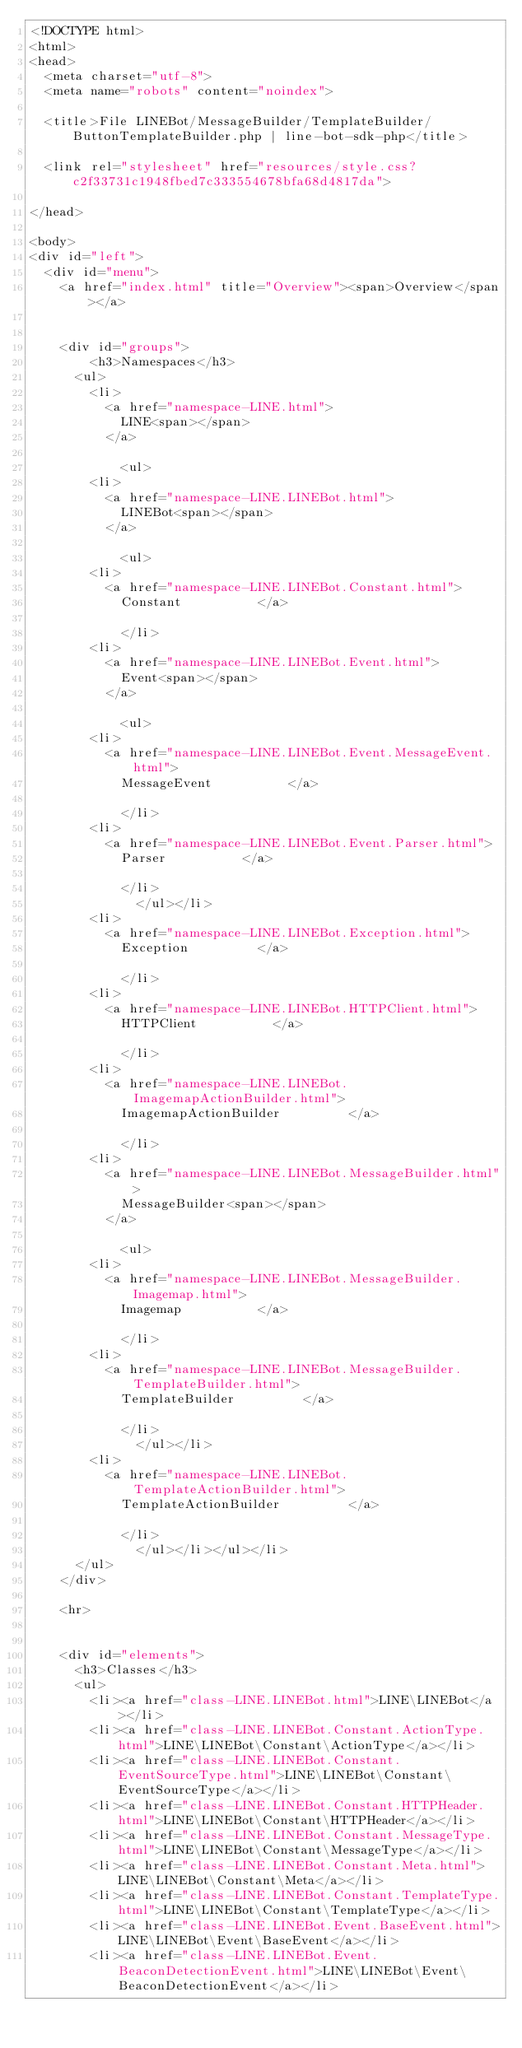Convert code to text. <code><loc_0><loc_0><loc_500><loc_500><_HTML_><!DOCTYPE html>
<html>
<head>
	<meta charset="utf-8">
	<meta name="robots" content="noindex">

	<title>File LINEBot/MessageBuilder/TemplateBuilder/ButtonTemplateBuilder.php | line-bot-sdk-php</title>

	<link rel="stylesheet" href="resources/style.css?c2f33731c1948fbed7c333554678bfa68d4817da">

</head>

<body>
<div id="left">
	<div id="menu">
		<a href="index.html" title="Overview"><span>Overview</span></a>


		<div id="groups">
				<h3>Namespaces</h3>
			<ul>
				<li>
					<a href="namespace-LINE.html">
						LINE<span></span>
					</a>

						<ul>
				<li>
					<a href="namespace-LINE.LINEBot.html">
						LINEBot<span></span>
					</a>

						<ul>
				<li>
					<a href="namespace-LINE.LINEBot.Constant.html">
						Constant					</a>

						</li>
				<li>
					<a href="namespace-LINE.LINEBot.Event.html">
						Event<span></span>
					</a>

						<ul>
				<li>
					<a href="namespace-LINE.LINEBot.Event.MessageEvent.html">
						MessageEvent					</a>

						</li>
				<li>
					<a href="namespace-LINE.LINEBot.Event.Parser.html">
						Parser					</a>

						</li>
							</ul></li>
				<li>
					<a href="namespace-LINE.LINEBot.Exception.html">
						Exception					</a>

						</li>
				<li>
					<a href="namespace-LINE.LINEBot.HTTPClient.html">
						HTTPClient					</a>

						</li>
				<li>
					<a href="namespace-LINE.LINEBot.ImagemapActionBuilder.html">
						ImagemapActionBuilder					</a>

						</li>
				<li>
					<a href="namespace-LINE.LINEBot.MessageBuilder.html">
						MessageBuilder<span></span>
					</a>

						<ul>
				<li>
					<a href="namespace-LINE.LINEBot.MessageBuilder.Imagemap.html">
						Imagemap					</a>

						</li>
				<li>
					<a href="namespace-LINE.LINEBot.MessageBuilder.TemplateBuilder.html">
						TemplateBuilder					</a>

						</li>
							</ul></li>
				<li>
					<a href="namespace-LINE.LINEBot.TemplateActionBuilder.html">
						TemplateActionBuilder					</a>

						</li>
							</ul></li></ul></li>
			</ul>
		</div>

		<hr>


		<div id="elements">
			<h3>Classes</h3>
			<ul>
				<li><a href="class-LINE.LINEBot.html">LINE\LINEBot</a></li>
				<li><a href="class-LINE.LINEBot.Constant.ActionType.html">LINE\LINEBot\Constant\ActionType</a></li>
				<li><a href="class-LINE.LINEBot.Constant.EventSourceType.html">LINE\LINEBot\Constant\EventSourceType</a></li>
				<li><a href="class-LINE.LINEBot.Constant.HTTPHeader.html">LINE\LINEBot\Constant\HTTPHeader</a></li>
				<li><a href="class-LINE.LINEBot.Constant.MessageType.html">LINE\LINEBot\Constant\MessageType</a></li>
				<li><a href="class-LINE.LINEBot.Constant.Meta.html">LINE\LINEBot\Constant\Meta</a></li>
				<li><a href="class-LINE.LINEBot.Constant.TemplateType.html">LINE\LINEBot\Constant\TemplateType</a></li>
				<li><a href="class-LINE.LINEBot.Event.BaseEvent.html">LINE\LINEBot\Event\BaseEvent</a></li>
				<li><a href="class-LINE.LINEBot.Event.BeaconDetectionEvent.html">LINE\LINEBot\Event\BeaconDetectionEvent</a></li></code> 